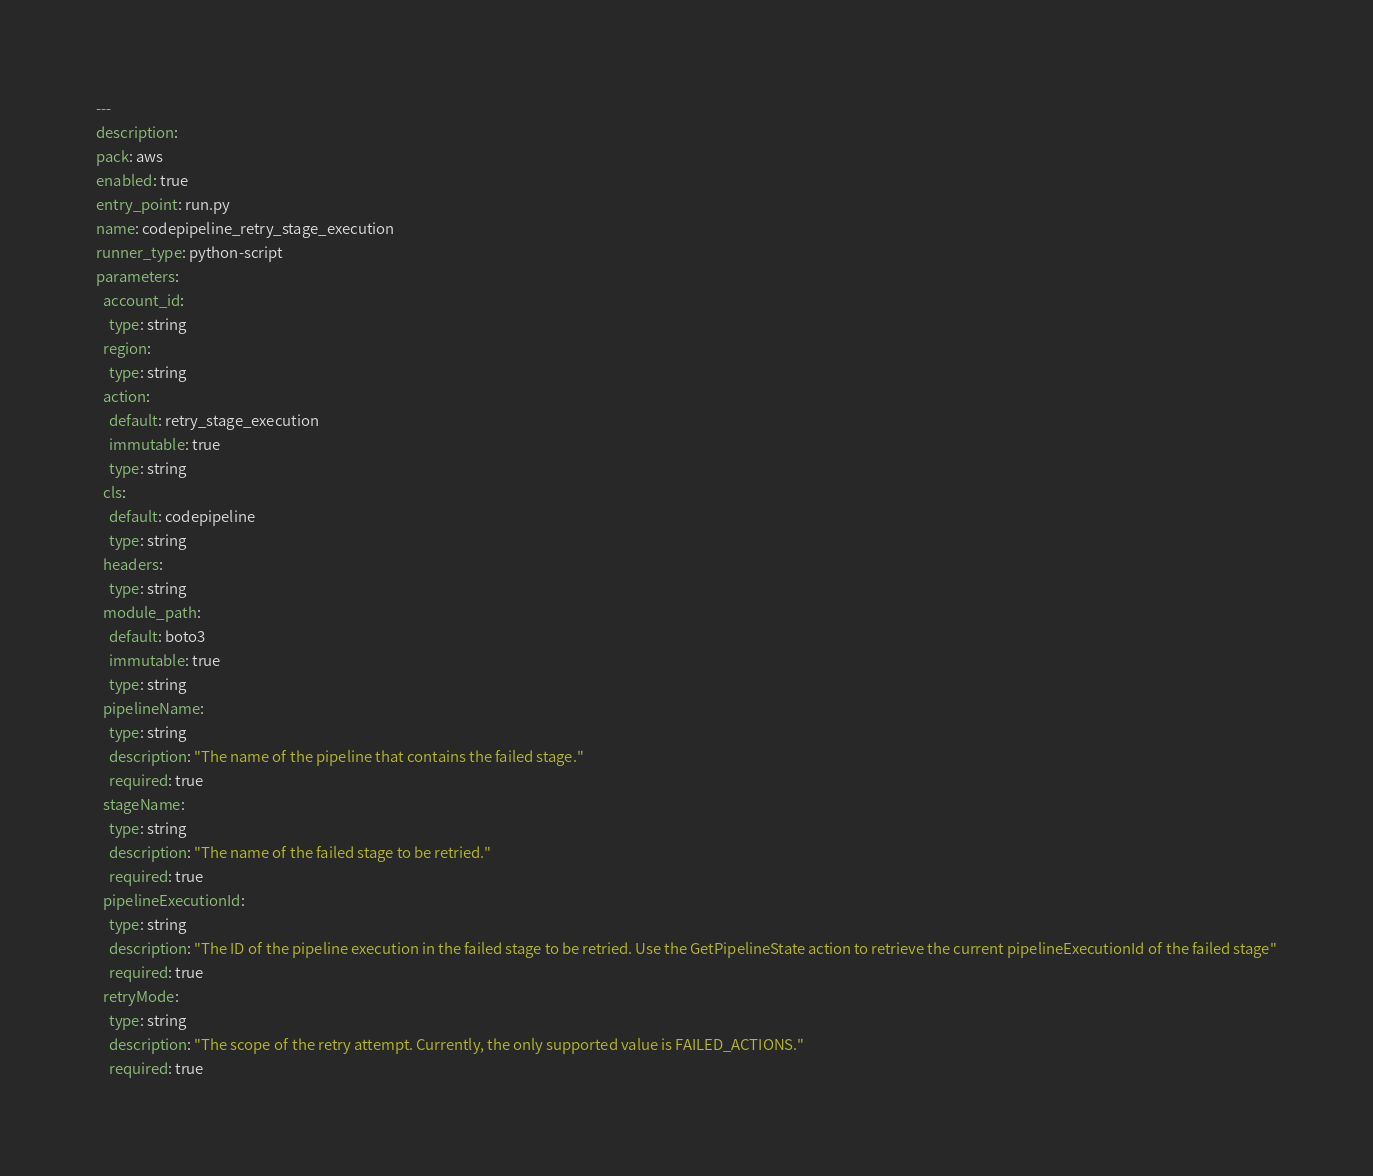Convert code to text. <code><loc_0><loc_0><loc_500><loc_500><_YAML_>---
description: 
pack: aws
enabled: true
entry_point: run.py
name: codepipeline_retry_stage_execution
runner_type: python-script
parameters:
  account_id:
    type: string
  region:
    type: string
  action:
    default: retry_stage_execution
    immutable: true
    type: string
  cls:
    default: codepipeline
    type: string
  headers:
    type: string
  module_path:
    default: boto3
    immutable: true
    type: string
  pipelineName:
    type: string
    description: "The name of the pipeline that contains the failed stage."
    required: true
  stageName:
    type: string
    description: "The name of the failed stage to be retried."
    required: true
  pipelineExecutionId:
    type: string
    description: "The ID of the pipeline execution in the failed stage to be retried. Use the GetPipelineState action to retrieve the current pipelineExecutionId of the failed stage"
    required: true
  retryMode:
    type: string
    description: "The scope of the retry attempt. Currently, the only supported value is FAILED_ACTIONS."
    required: true</code> 